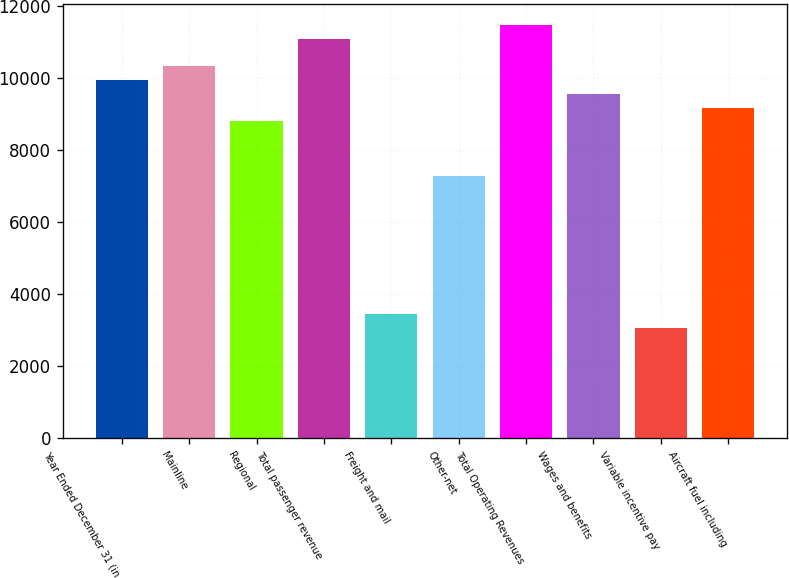Convert chart to OTSL. <chart><loc_0><loc_0><loc_500><loc_500><bar_chart><fcel>Year Ended December 31 (in<fcel>Mainline<fcel>Regional<fcel>Total passenger revenue<fcel>Freight and mail<fcel>Other-net<fcel>Total Operating Revenues<fcel>Wages and benefits<fcel>Variable incentive pay<fcel>Aircraft fuel including<nl><fcel>9954.06<fcel>10336.7<fcel>8806.23<fcel>11101.9<fcel>3449.69<fcel>7275.79<fcel>11484.5<fcel>9571.45<fcel>3067.08<fcel>9188.84<nl></chart> 